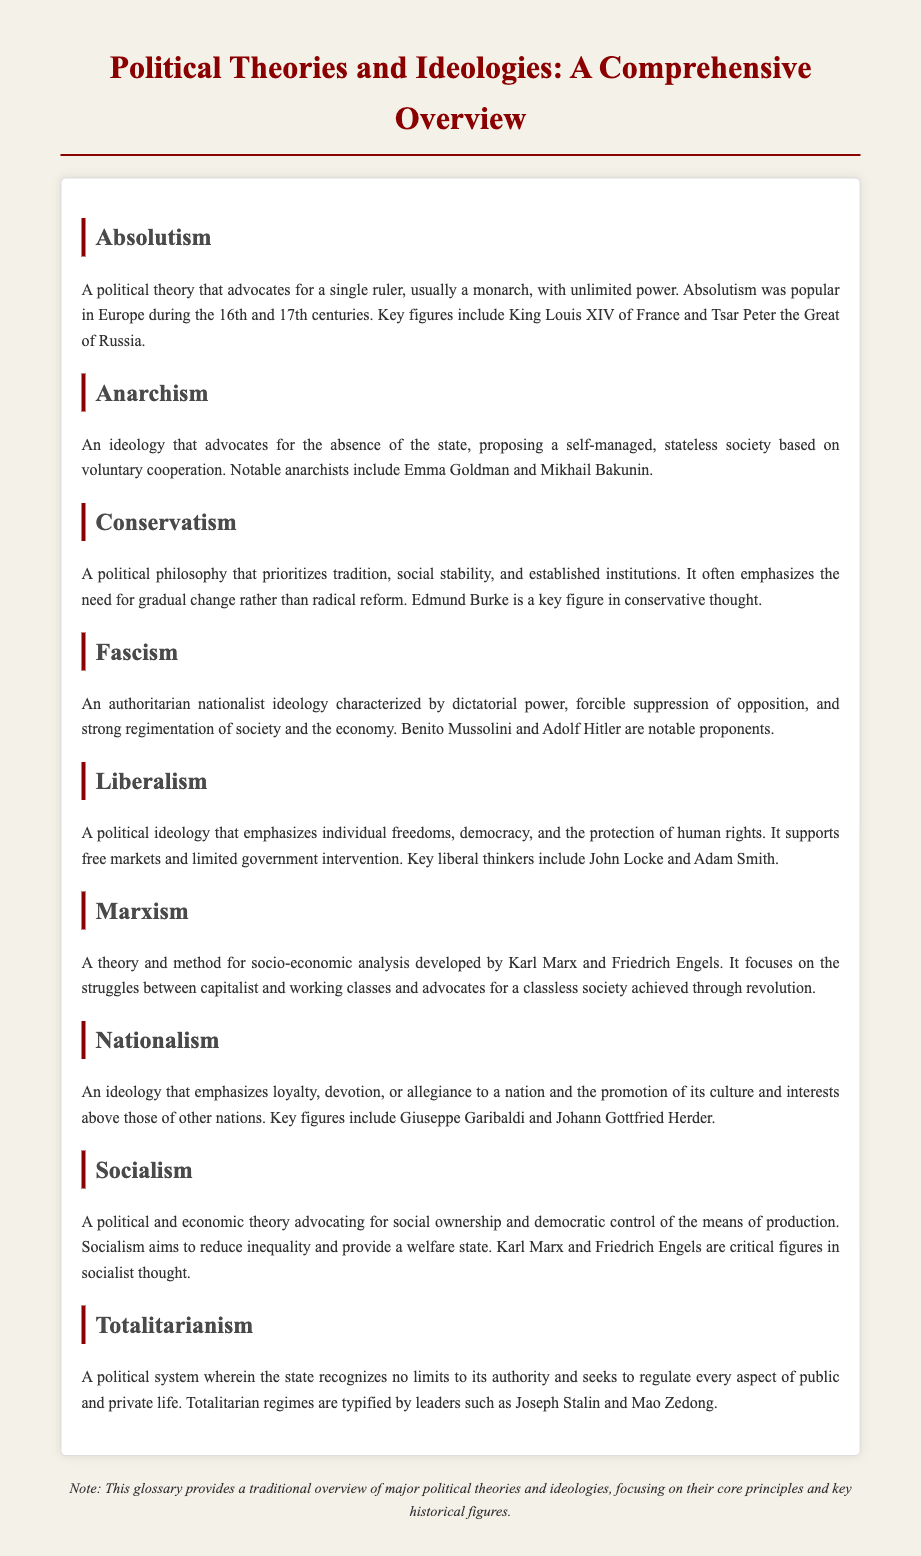What is the definition of Absolutism? Absolutism is defined as a political theory that advocates for a single ruler, usually a monarch, with unlimited power.
Answer: A political theory that advocates for a single ruler, usually a monarch, with unlimited power Who is a notable figure in Anarchism? The document mentions Emma Goldman as a notable anarchist.
Answer: Emma Goldman What ideology emphasizes tradition and social stability? The ideology that prioritizes tradition and social stability is Conservatism.
Answer: Conservatism What political theory is characterized by dictatorial power and suppression of opposition? The political theory that is characterized by dictatorial power and suppression of opposition is Fascism.
Answer: Fascism Which political ideology supports free markets and limited government intervention? The political ideology that supports free markets and limited government intervention is Liberalism.
Answer: Liberalism What is the focus of Marxism? Marxism focuses on the struggles between capitalist and working classes and advocates for a classless society achieved through revolution.
Answer: The struggles between capitalist and working classes Who are key figures in Socialist thought? The key figures in Socialist thought mentioned are Karl Marx and Friedrich Engels.
Answer: Karl Marx and Friedrich Engels What does Nationalism promote? Nationalism emphasizes loyalty, devotion, or allegiance to a nation and the promotion of its culture and interests above those of other nations.
Answer: Loyalty to a nation What is the central aim of Socialism? The central aim of Socialism is to reduce inequality and provide a welfare state.
Answer: To reduce inequality and provide a welfare state What type of document is this? This document is categorized as a glossary.
Answer: Glossary 